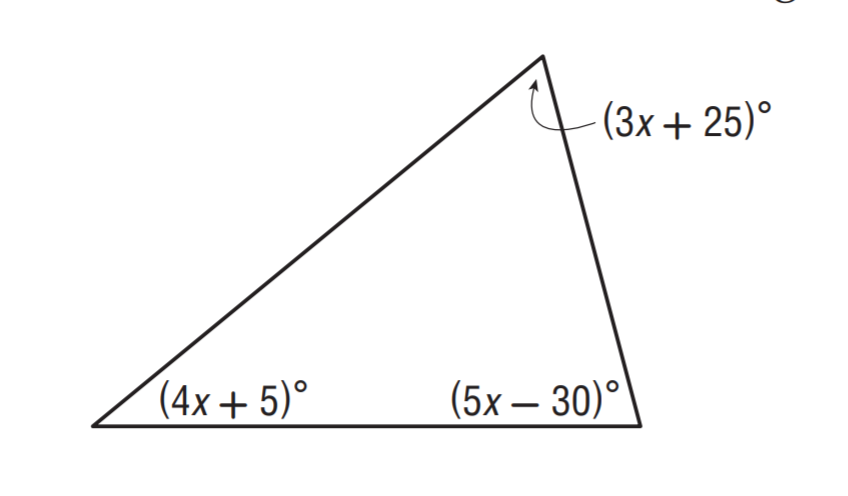Question: Solve for x.
Choices:
A. 10
B. 15
C. 25
D. 30
Answer with the letter. Answer: B 